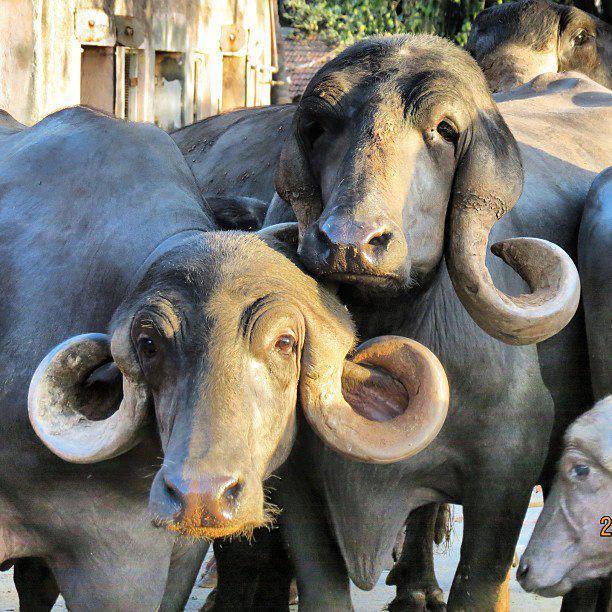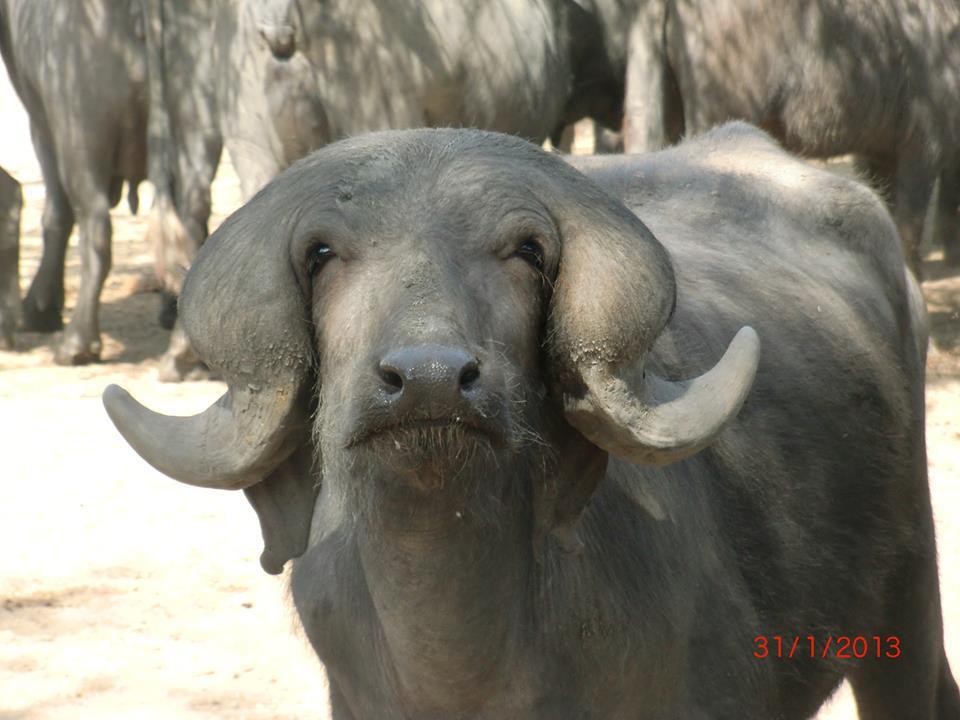The first image is the image on the left, the second image is the image on the right. For the images shown, is this caption "The animals in the left image are next to a man made structure." true? Answer yes or no. Yes. The first image is the image on the left, the second image is the image on the right. Examine the images to the left and right. Is the description "The foreground of each image contains water buffalo who look directly forward, and one image contains a single water buffalo in the foreground." accurate? Answer yes or no. Yes. 